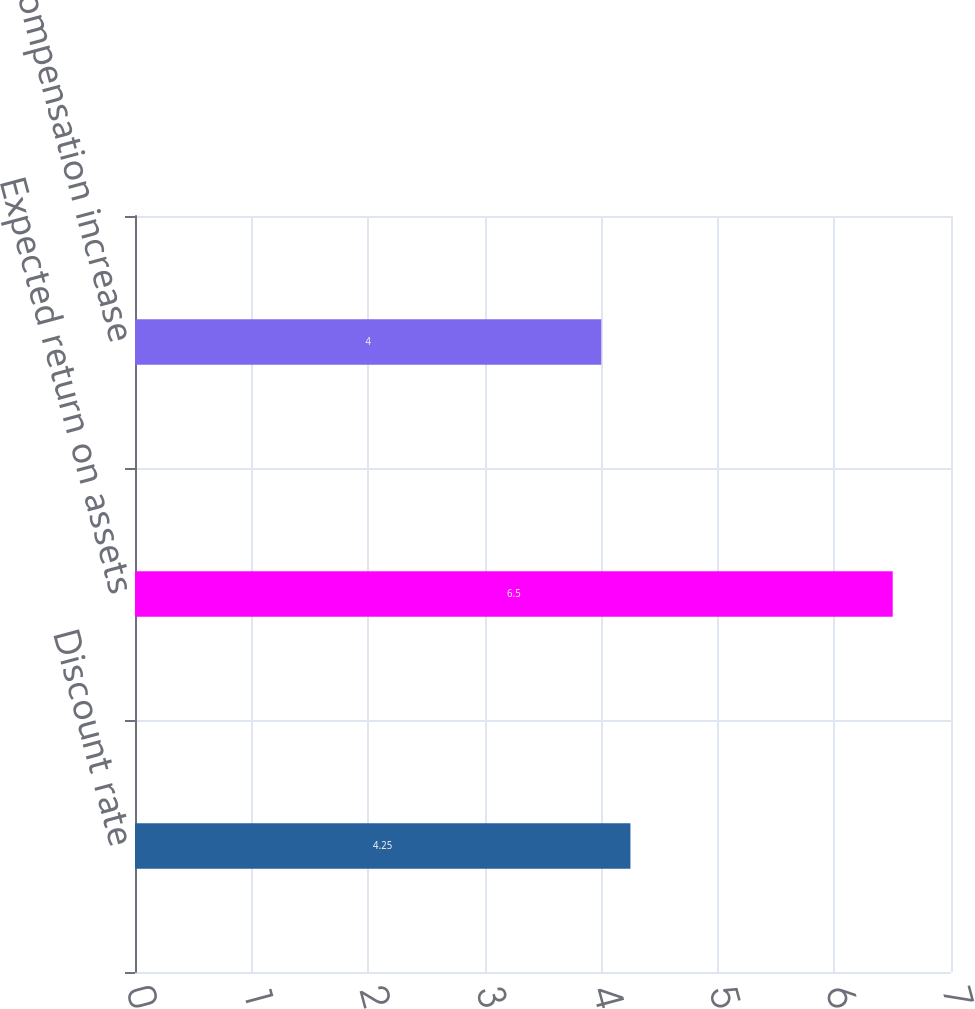Convert chart to OTSL. <chart><loc_0><loc_0><loc_500><loc_500><bar_chart><fcel>Discount rate<fcel>Expected return on assets<fcel>Rate of compensation increase<nl><fcel>4.25<fcel>6.5<fcel>4<nl></chart> 